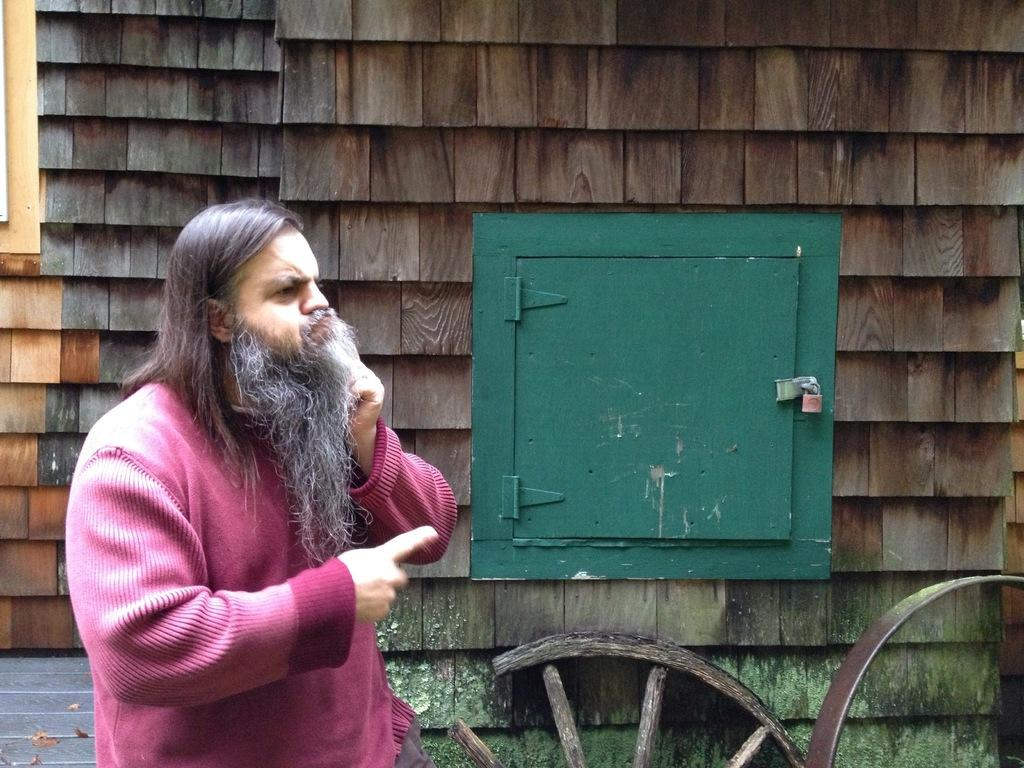Who is in the image? There is a person in the image. What is the person wearing? The person is wearing a pink shirt. What can be seen in the image besides the person? There is a door in the image. What color is the door? The door is green. What is the color of the background in the image? The background of the image is brown. Can you tell me how many times the person in the image turns on the power switch? There is no power switch or indication of turning it on in the image. 